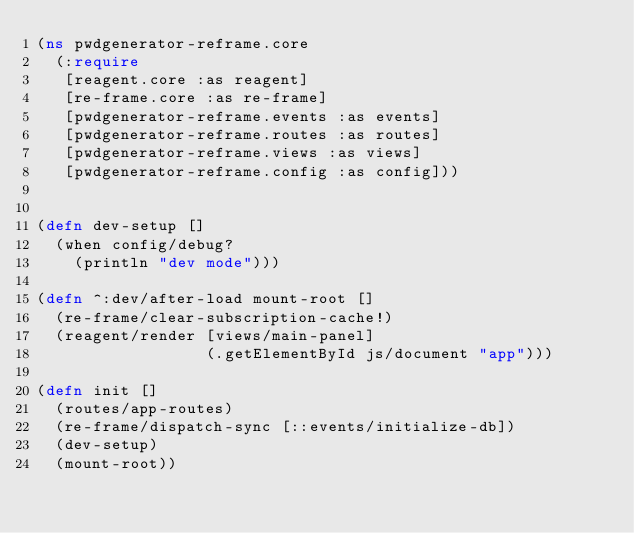Convert code to text. <code><loc_0><loc_0><loc_500><loc_500><_Clojure_>(ns pwdgenerator-reframe.core
  (:require
   [reagent.core :as reagent]
   [re-frame.core :as re-frame]
   [pwdgenerator-reframe.events :as events]
   [pwdgenerator-reframe.routes :as routes]
   [pwdgenerator-reframe.views :as views]
   [pwdgenerator-reframe.config :as config]))


(defn dev-setup []
  (when config/debug?
    (println "dev mode")))

(defn ^:dev/after-load mount-root []
  (re-frame/clear-subscription-cache!)
  (reagent/render [views/main-panel]
                  (.getElementById js/document "app")))

(defn init []
  (routes/app-routes)
  (re-frame/dispatch-sync [::events/initialize-db])
  (dev-setup)
  (mount-root))
</code> 